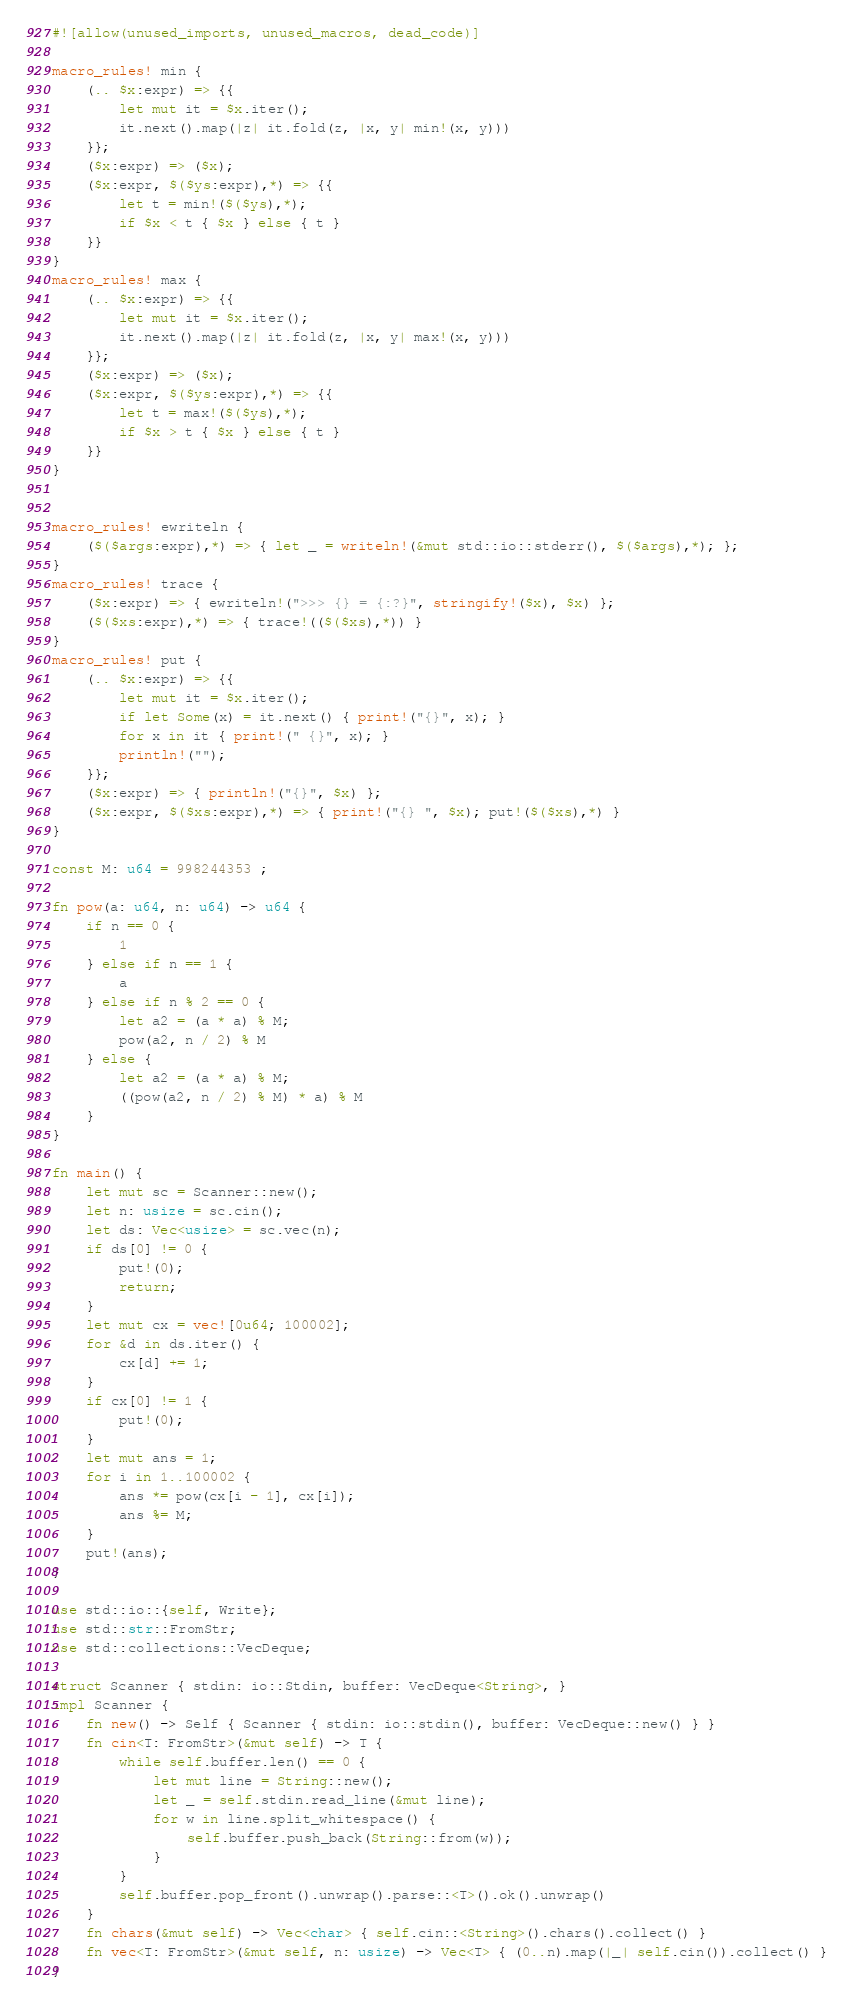<code> <loc_0><loc_0><loc_500><loc_500><_Rust_>#![allow(unused_imports, unused_macros, dead_code)]

macro_rules! min {
    (.. $x:expr) => {{
        let mut it = $x.iter();
        it.next().map(|z| it.fold(z, |x, y| min!(x, y)))
    }};
    ($x:expr) => ($x);
    ($x:expr, $($ys:expr),*) => {{
        let t = min!($($ys),*);
        if $x < t { $x } else { t }
    }}
}
macro_rules! max {
    (.. $x:expr) => {{
        let mut it = $x.iter();
        it.next().map(|z| it.fold(z, |x, y| max!(x, y)))
    }};
    ($x:expr) => ($x);
    ($x:expr, $($ys:expr),*) => {{
        let t = max!($($ys),*);
        if $x > t { $x } else { t }
    }}
}


macro_rules! ewriteln {
    ($($args:expr),*) => { let _ = writeln!(&mut std::io::stderr(), $($args),*); };
}
macro_rules! trace {
    ($x:expr) => { ewriteln!(">>> {} = {:?}", stringify!($x), $x) };
    ($($xs:expr),*) => { trace!(($($xs),*)) }
}
macro_rules! put {
    (.. $x:expr) => {{
        let mut it = $x.iter();
        if let Some(x) = it.next() { print!("{}", x); }
        for x in it { print!(" {}", x); }
        println!("");
    }};
    ($x:expr) => { println!("{}", $x) };
    ($x:expr, $($xs:expr),*) => { print!("{} ", $x); put!($($xs),*) }
}

const M: u64 = 998244353 ;

fn pow(a: u64, n: u64) -> u64 {
    if n == 0 {
        1
    } else if n == 1 {
        a
    } else if n % 2 == 0 {
        let a2 = (a * a) % M;
        pow(a2, n / 2) % M
    } else {
        let a2 = (a * a) % M;
        ((pow(a2, n / 2) % M) * a) % M
    }
}

fn main() {
    let mut sc = Scanner::new();
    let n: usize = sc.cin();
    let ds: Vec<usize> = sc.vec(n);
    if ds[0] != 0 {
        put!(0);
        return;
    }
    let mut cx = vec![0u64; 100002];
    for &d in ds.iter() {
        cx[d] += 1;
    }
    if cx[0] != 1 {
        put!(0);
    }
    let mut ans = 1;
    for i in 1..100002 {
        ans *= pow(cx[i - 1], cx[i]);
        ans %= M;
    }
    put!(ans);
}

use std::io::{self, Write};
use std::str::FromStr;
use std::collections::VecDeque;

struct Scanner { stdin: io::Stdin, buffer: VecDeque<String>, }
impl Scanner {
    fn new() -> Self { Scanner { stdin: io::stdin(), buffer: VecDeque::new() } }
    fn cin<T: FromStr>(&mut self) -> T {
        while self.buffer.len() == 0 {
            let mut line = String::new();
            let _ = self.stdin.read_line(&mut line);
            for w in line.split_whitespace() {
                self.buffer.push_back(String::from(w));
            }
        }
        self.buffer.pop_front().unwrap().parse::<T>().ok().unwrap()
    }
    fn chars(&mut self) -> Vec<char> { self.cin::<String>().chars().collect() }
    fn vec<T: FromStr>(&mut self, n: usize) -> Vec<T> { (0..n).map(|_| self.cin()).collect() }
}
</code> 